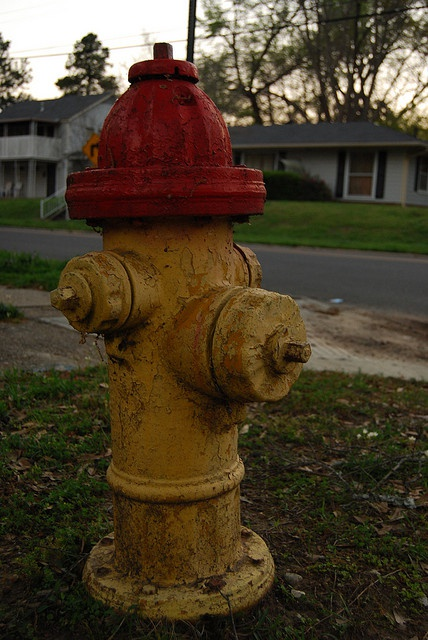Describe the objects in this image and their specific colors. I can see a fire hydrant in white, maroon, black, and olive tones in this image. 